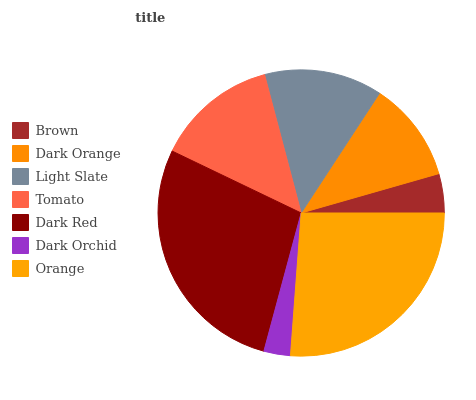Is Dark Orchid the minimum?
Answer yes or no. Yes. Is Dark Red the maximum?
Answer yes or no. Yes. Is Dark Orange the minimum?
Answer yes or no. No. Is Dark Orange the maximum?
Answer yes or no. No. Is Dark Orange greater than Brown?
Answer yes or no. Yes. Is Brown less than Dark Orange?
Answer yes or no. Yes. Is Brown greater than Dark Orange?
Answer yes or no. No. Is Dark Orange less than Brown?
Answer yes or no. No. Is Light Slate the high median?
Answer yes or no. Yes. Is Light Slate the low median?
Answer yes or no. Yes. Is Brown the high median?
Answer yes or no. No. Is Brown the low median?
Answer yes or no. No. 